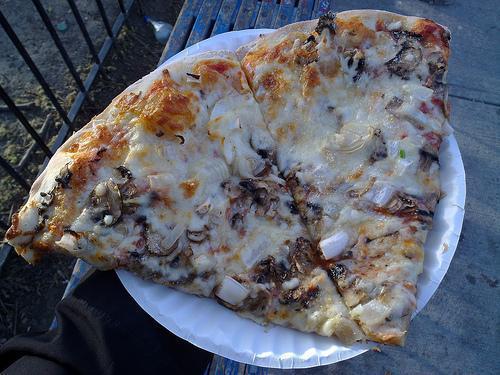How many slices of pizza are there?
Give a very brief answer. 2. 